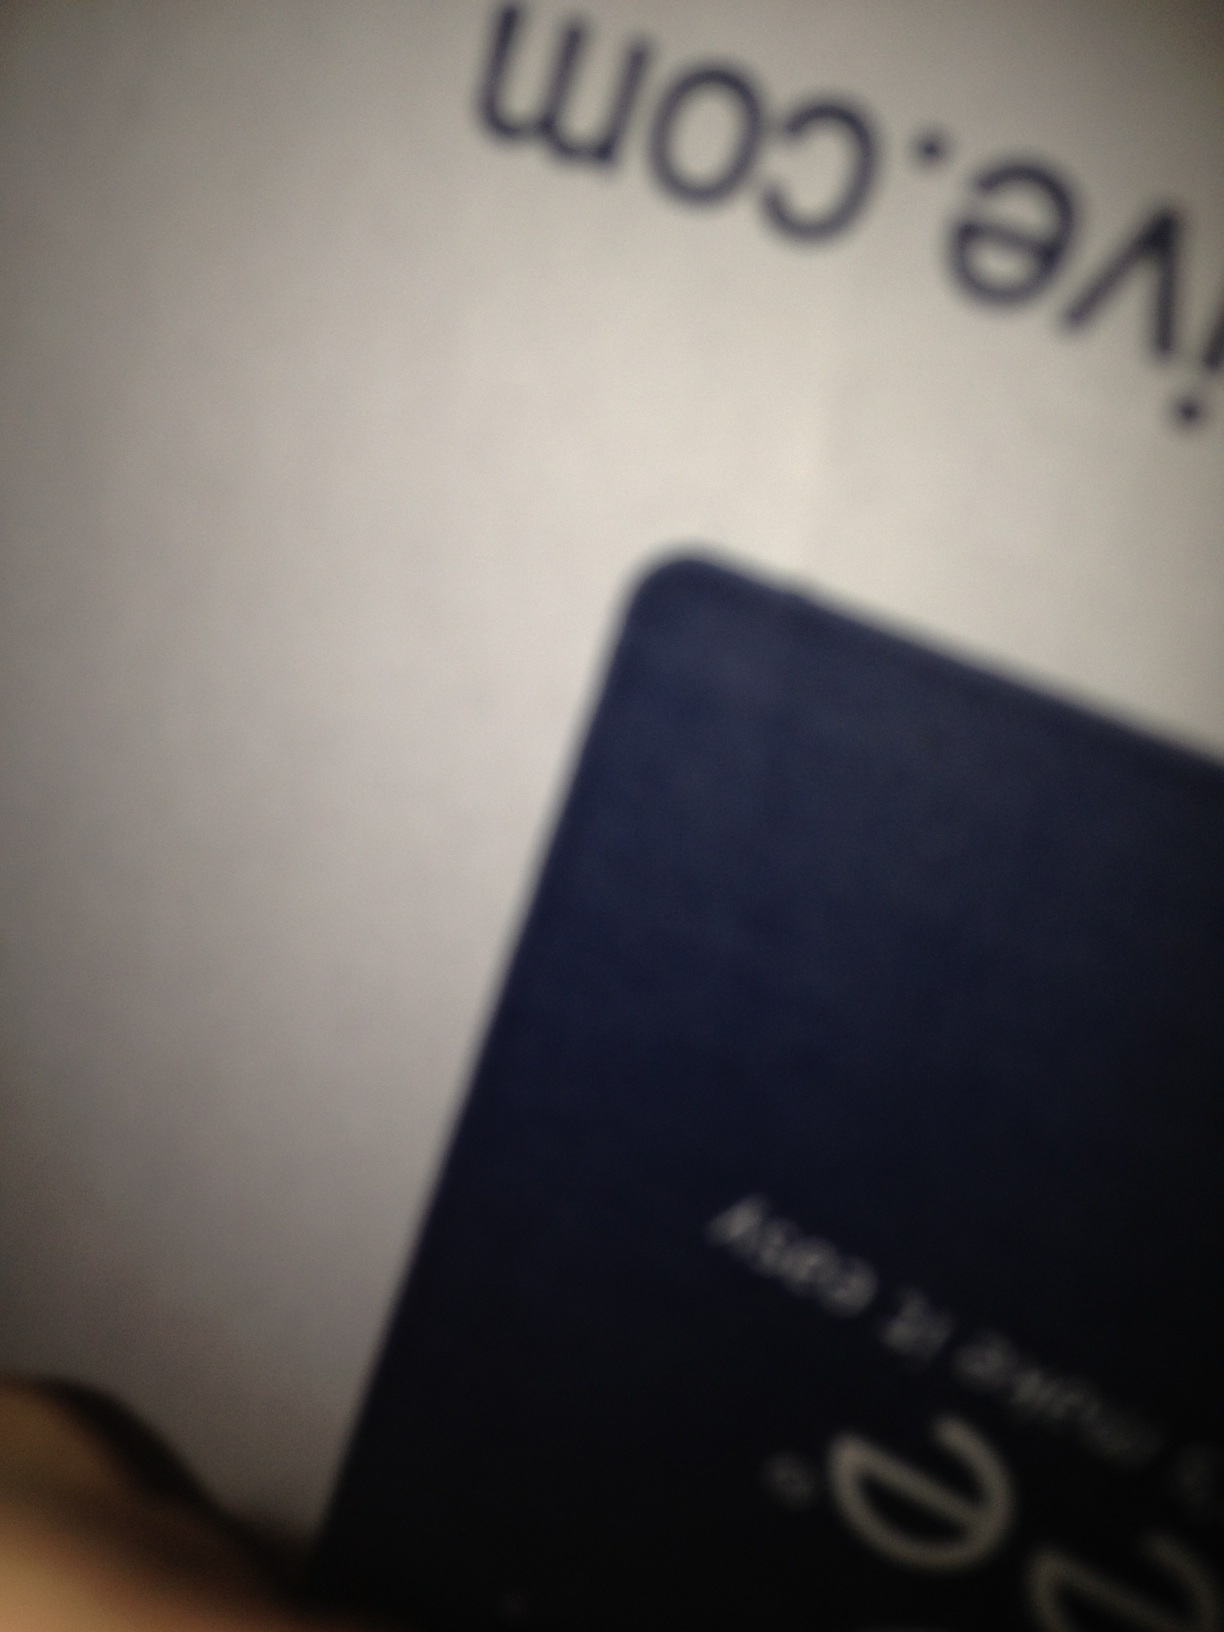What is this box? Due to the blurriness of the photograph, it's challenging to determine the exact nature of the box shown. It appears to be a common type of packaging or storage box, potentially for electronics or consumer goods, but a clearer image or more context would be necessary for a precise identification. 